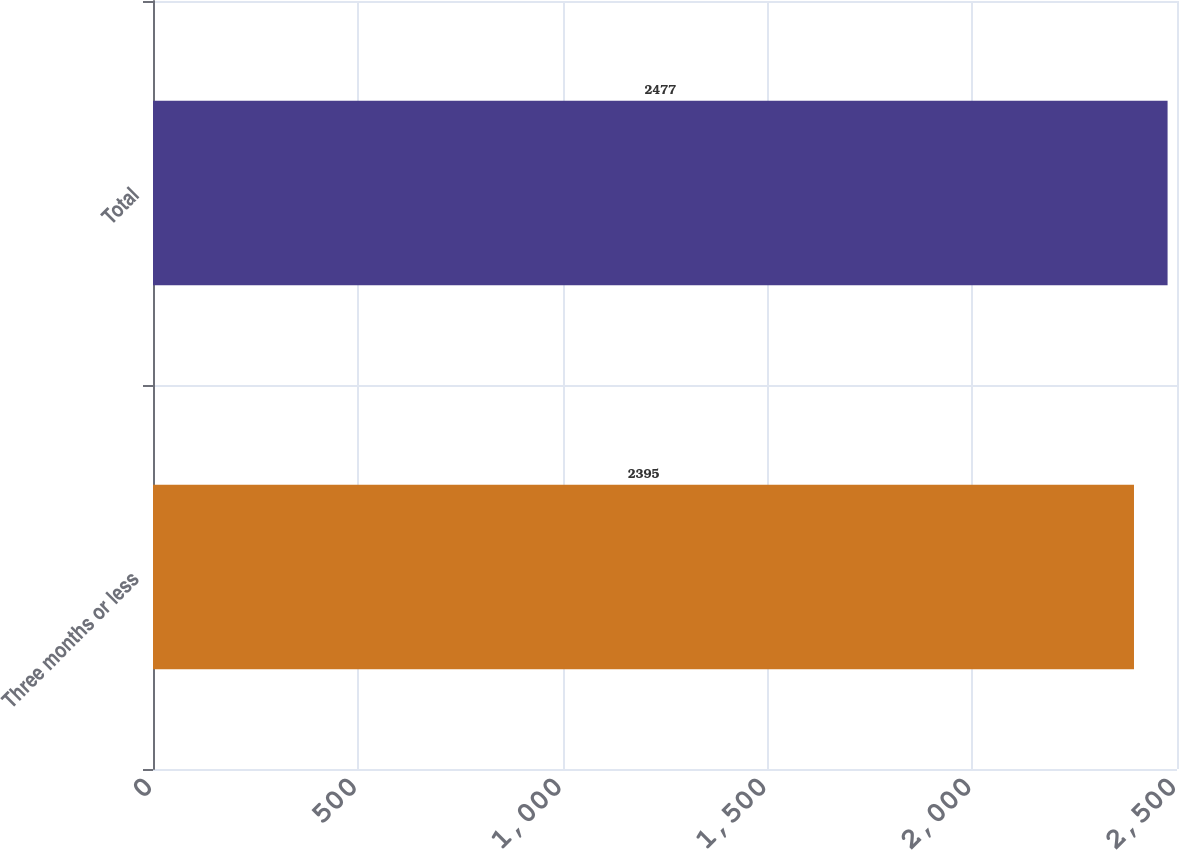Convert chart to OTSL. <chart><loc_0><loc_0><loc_500><loc_500><bar_chart><fcel>Three months or less<fcel>Total<nl><fcel>2395<fcel>2477<nl></chart> 